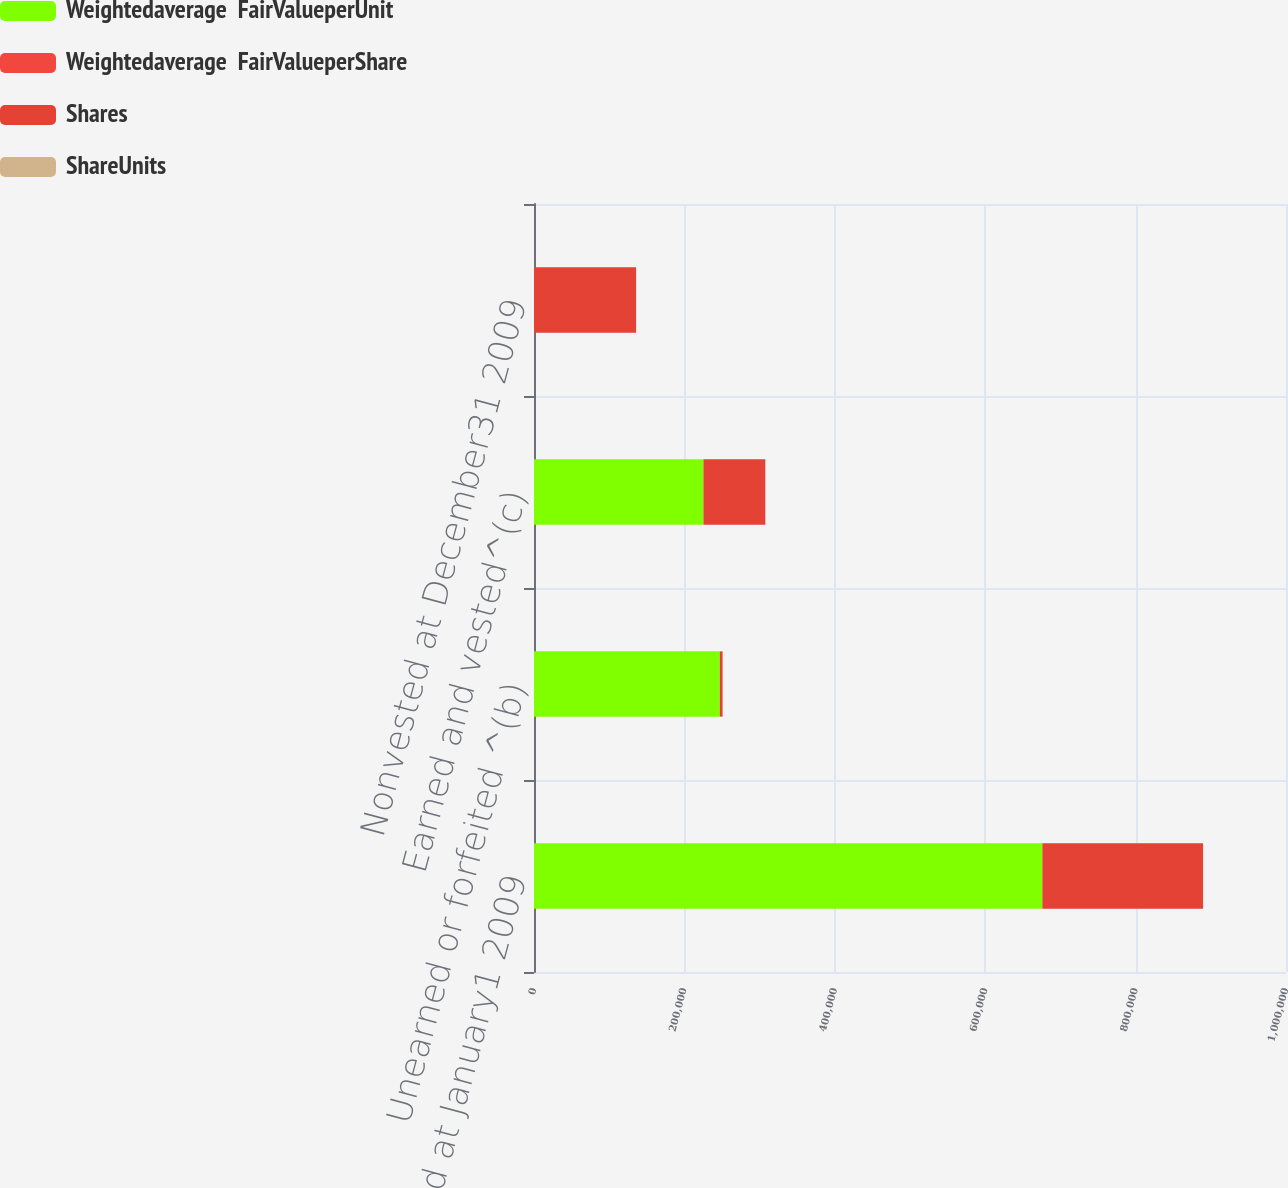<chart> <loc_0><loc_0><loc_500><loc_500><stacked_bar_chart><ecel><fcel>Nonvested at January1 2009<fcel>Unearned or forfeited ^(b)<fcel>Earned and vested^(c)<fcel>Nonvested at December31 2009<nl><fcel>Weightedaverage  FairValueperUnit<fcel>675977<fcel>247065<fcel>225313<fcel>57.15<nl><fcel>Weightedaverage  FairValueperShare<fcel>43.28<fcel>57.15<fcel>25.66<fcel>22.07<nl><fcel>Shares<fcel>213683<fcel>3644<fcel>82277<fcel>135696<nl><fcel>ShareUnits<fcel>47.46<fcel>48.3<fcel>45.15<fcel>48.92<nl></chart> 